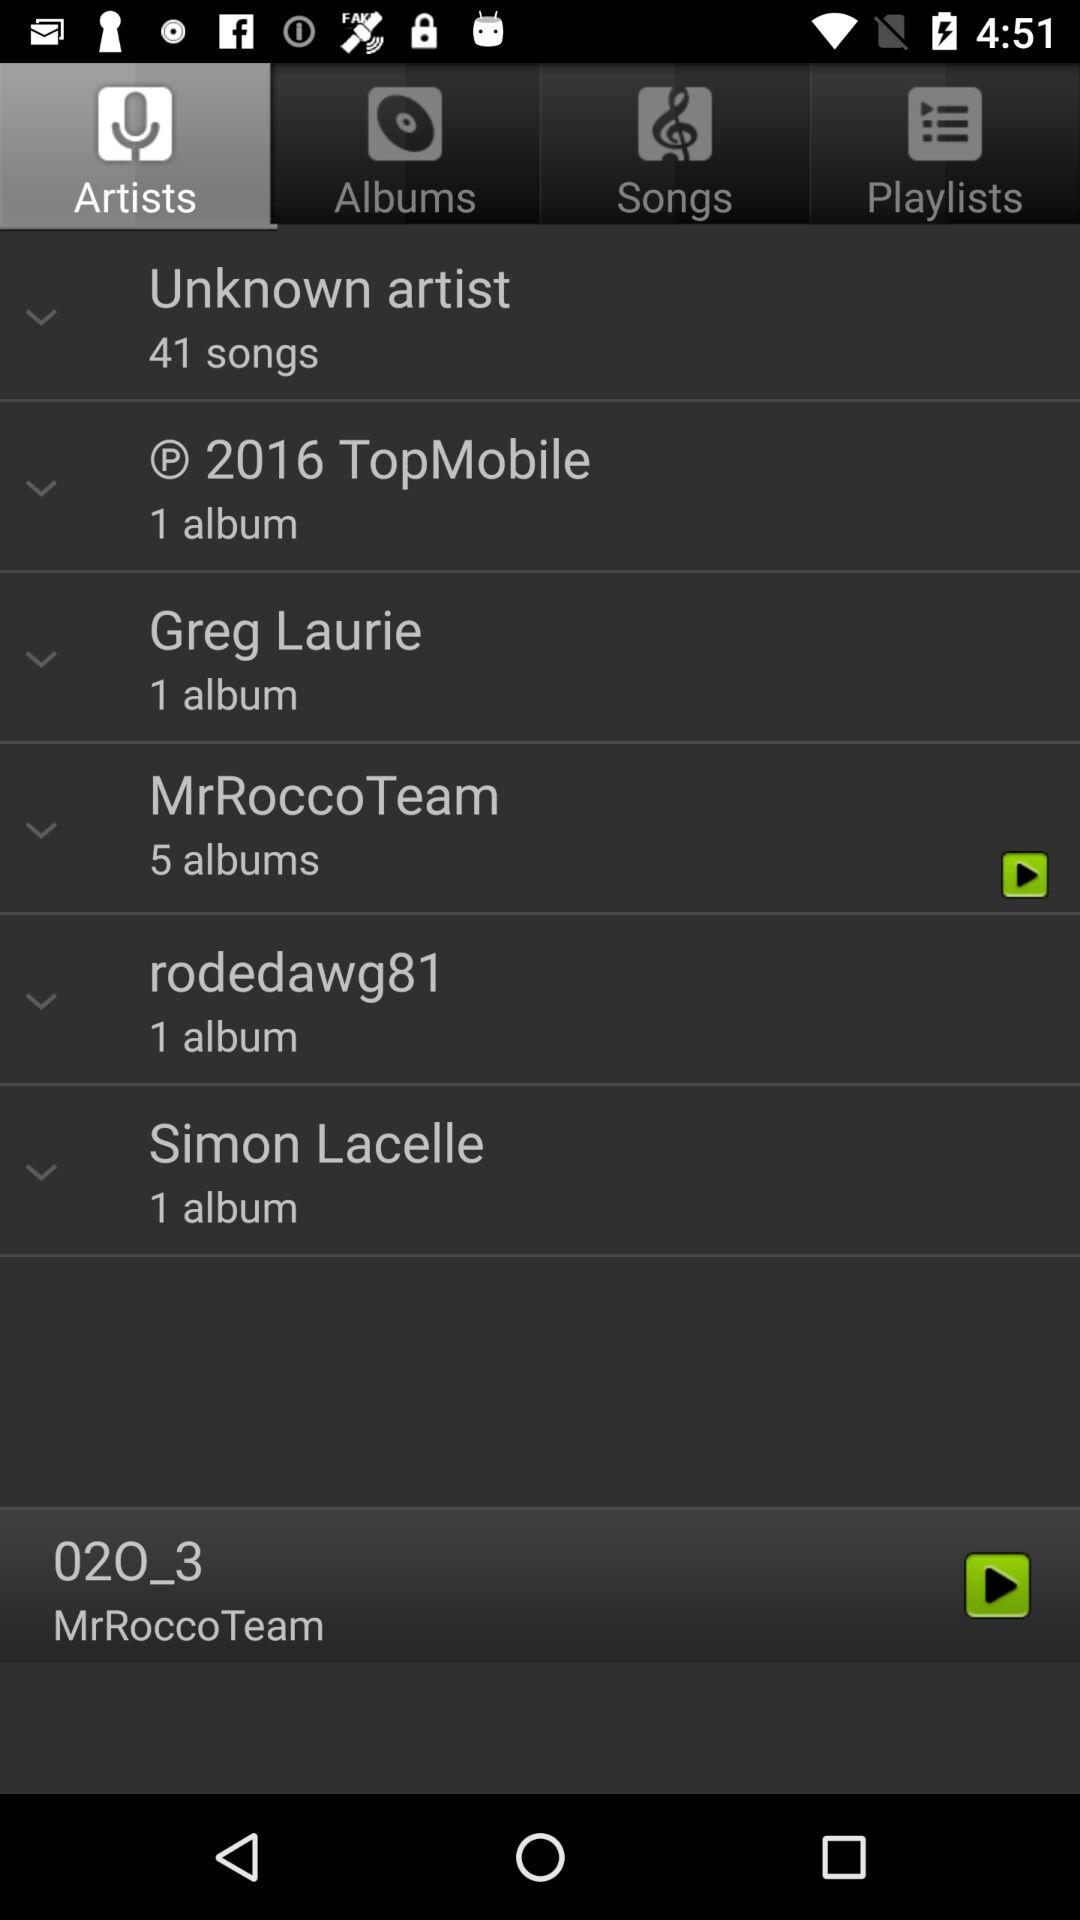How many albums are there by Simon Lacelle? There is 1 album by Simon Lacelle. 